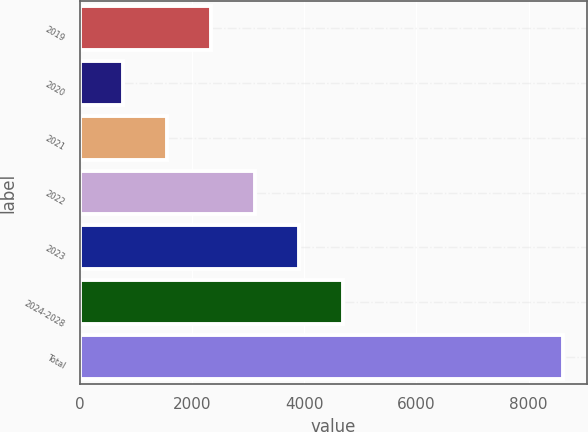Convert chart to OTSL. <chart><loc_0><loc_0><loc_500><loc_500><bar_chart><fcel>2019<fcel>2020<fcel>2021<fcel>2022<fcel>2023<fcel>2024-2028<fcel>Total<nl><fcel>2342.4<fcel>776<fcel>1559.2<fcel>3125.6<fcel>3908.8<fcel>4692<fcel>8608<nl></chart> 